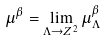Convert formula to latex. <formula><loc_0><loc_0><loc_500><loc_500>\mu ^ { \beta } = \lim _ { \Lambda \rightarrow { Z } ^ { 2 } } \mu _ { \Lambda } ^ { \beta }</formula> 